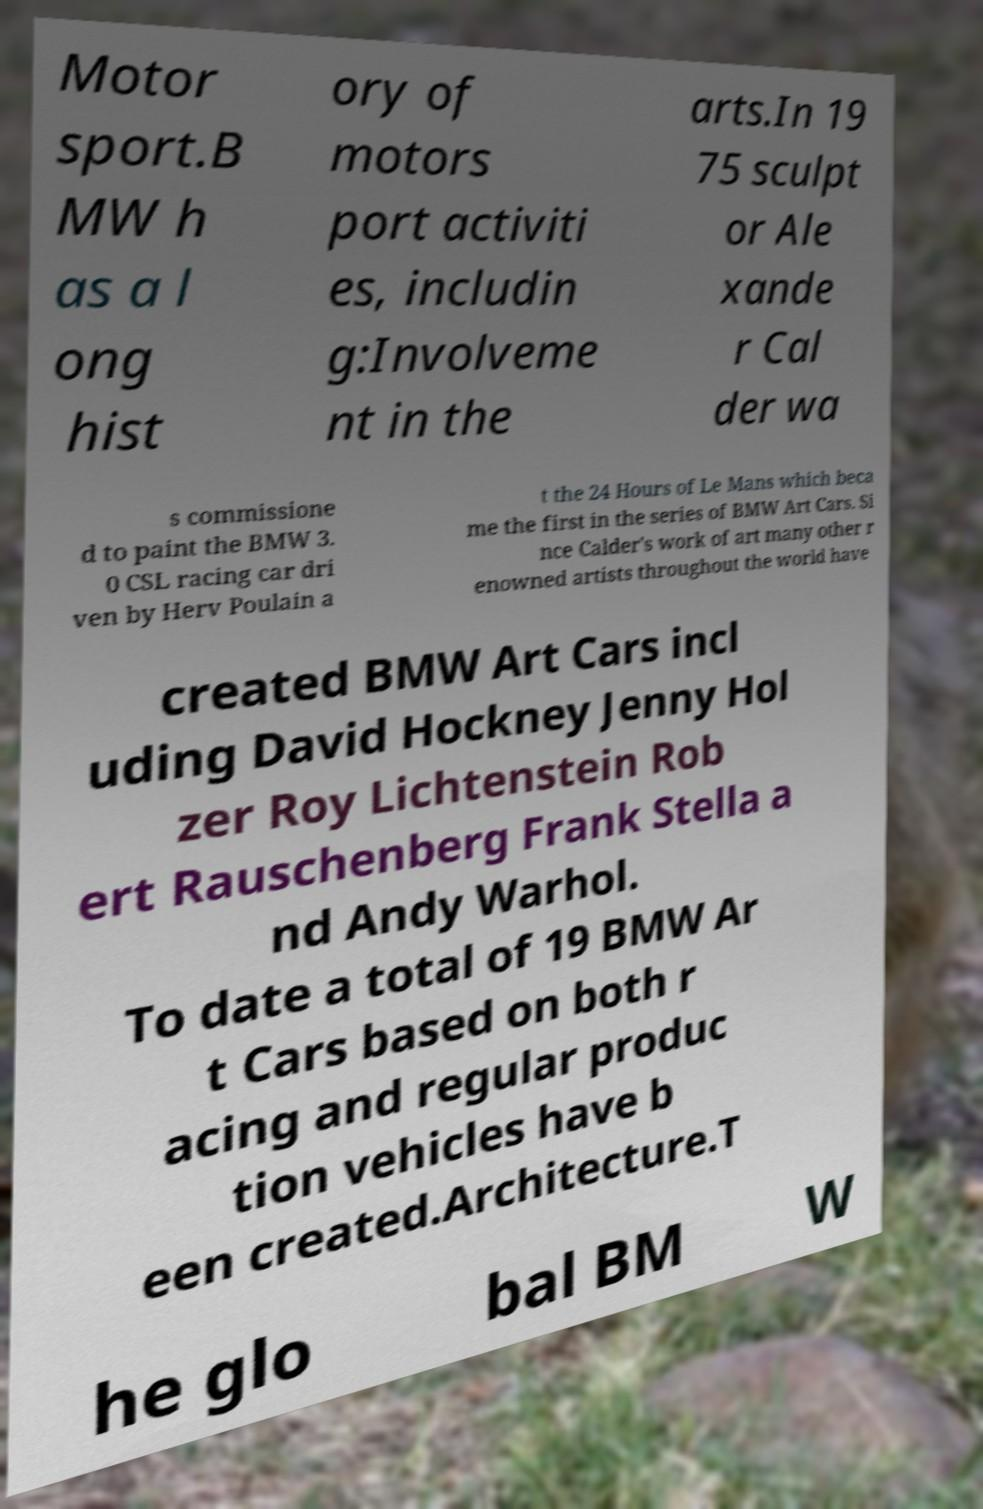For documentation purposes, I need the text within this image transcribed. Could you provide that? Motor sport.B MW h as a l ong hist ory of motors port activiti es, includin g:Involveme nt in the arts.In 19 75 sculpt or Ale xande r Cal der wa s commissione d to paint the BMW 3. 0 CSL racing car dri ven by Herv Poulain a t the 24 Hours of Le Mans which beca me the first in the series of BMW Art Cars. Si nce Calder's work of art many other r enowned artists throughout the world have created BMW Art Cars incl uding David Hockney Jenny Hol zer Roy Lichtenstein Rob ert Rauschenberg Frank Stella a nd Andy Warhol. To date a total of 19 BMW Ar t Cars based on both r acing and regular produc tion vehicles have b een created.Architecture.T he glo bal BM W 